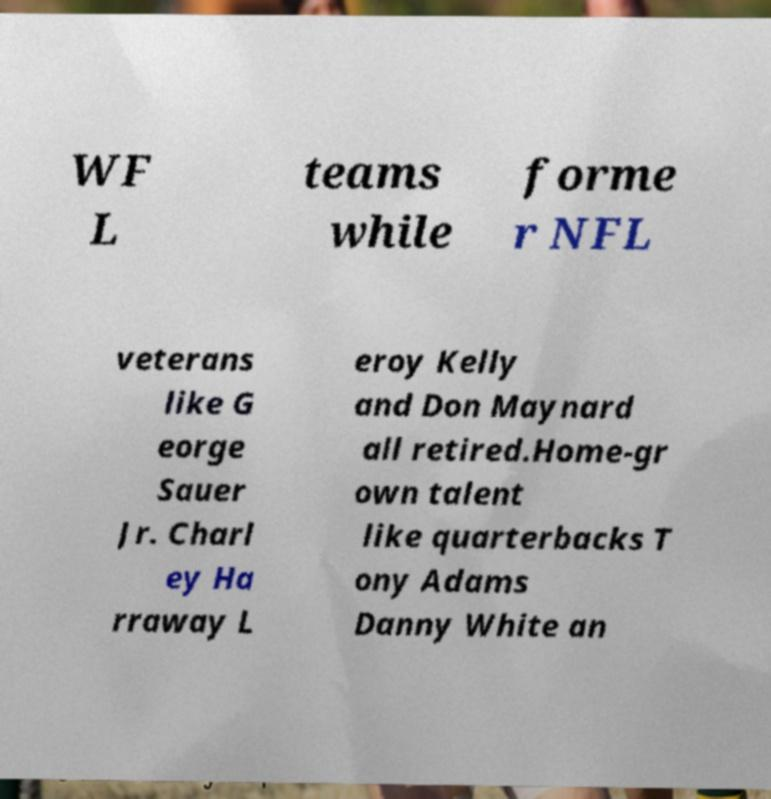Can you read and provide the text displayed in the image?This photo seems to have some interesting text. Can you extract and type it out for me? WF L teams while forme r NFL veterans like G eorge Sauer Jr. Charl ey Ha rraway L eroy Kelly and Don Maynard all retired.Home-gr own talent like quarterbacks T ony Adams Danny White an 